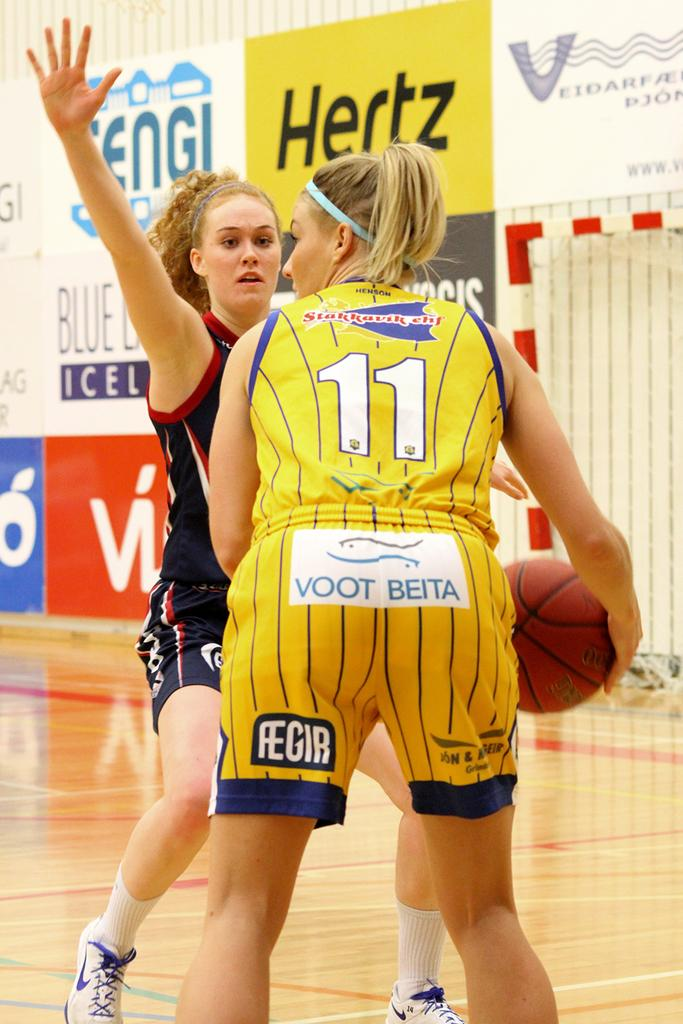<image>
Render a clear and concise summary of the photo. Player number 11 has shorts on that say Voot Beita across the butt. 